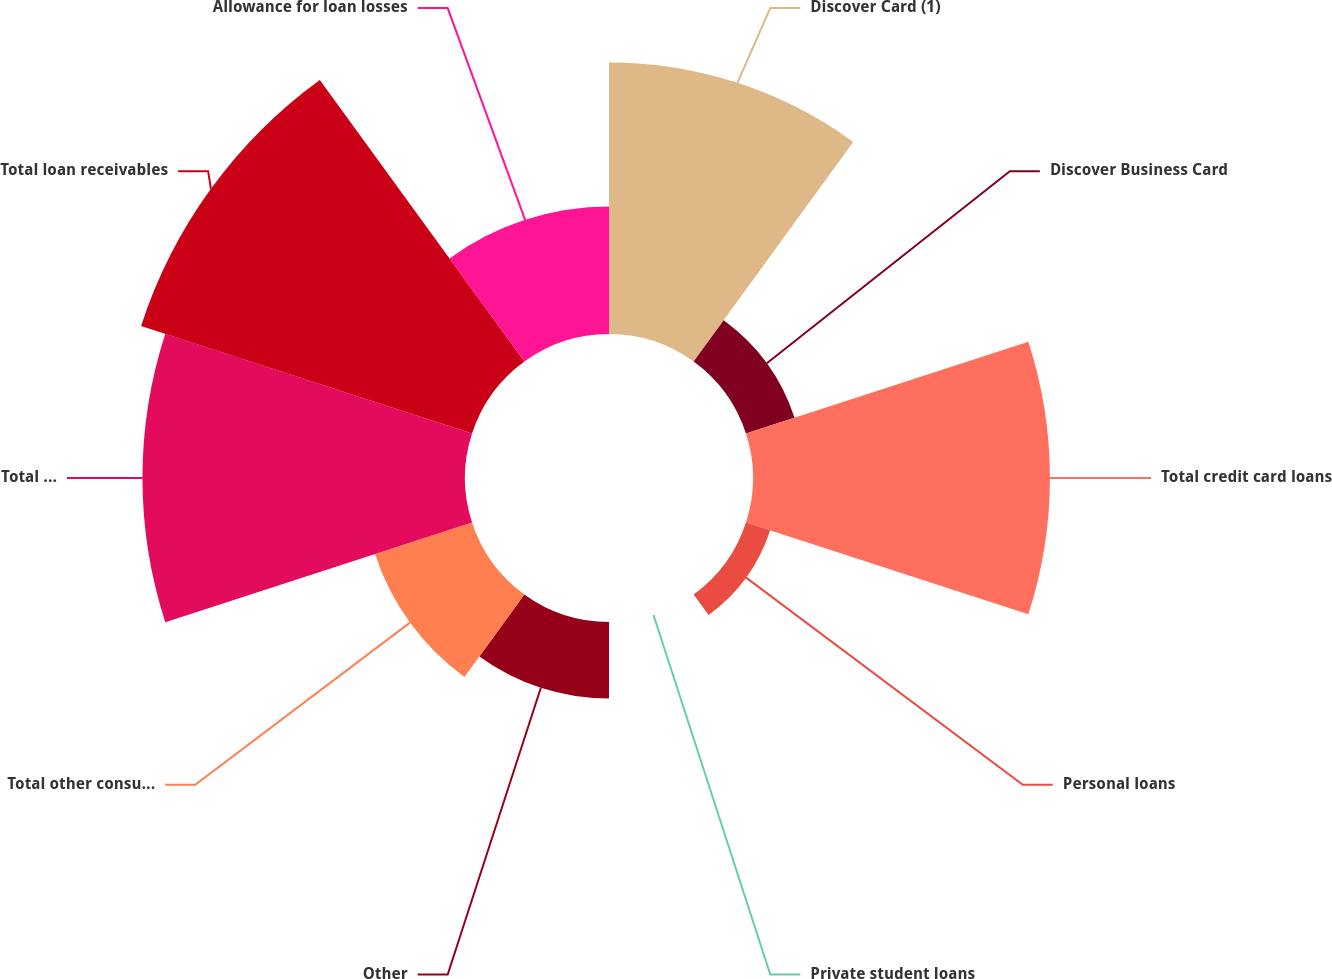Convert chart. <chart><loc_0><loc_0><loc_500><loc_500><pie_chart><fcel>Discover Card (1)<fcel>Discover Business Card<fcel>Total credit card loans<fcel>Personal loans<fcel>Private student loans<fcel>Other<fcel>Total other consumer loans<fcel>Total loan portfolio<fcel>Total loan receivables<fcel>Allowance for loan losses<nl><fcel>16.74%<fcel>3.15%<fcel>18.31%<fcel>1.57%<fcel>0.0%<fcel>4.72%<fcel>6.29%<fcel>19.89%<fcel>21.46%<fcel>7.86%<nl></chart> 